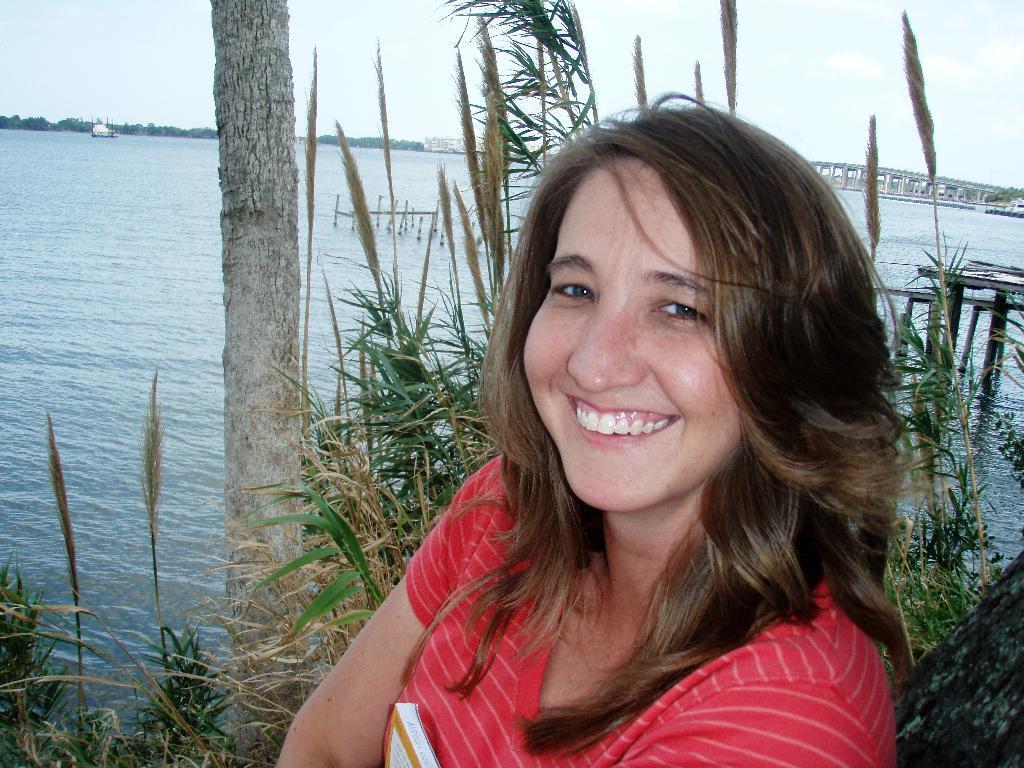In one or two sentences, can you explain what this image depicts? In the picture there is a woman in the foreground, she is laughing and behind her there are few plants and a water surface, in the background there are trees. 